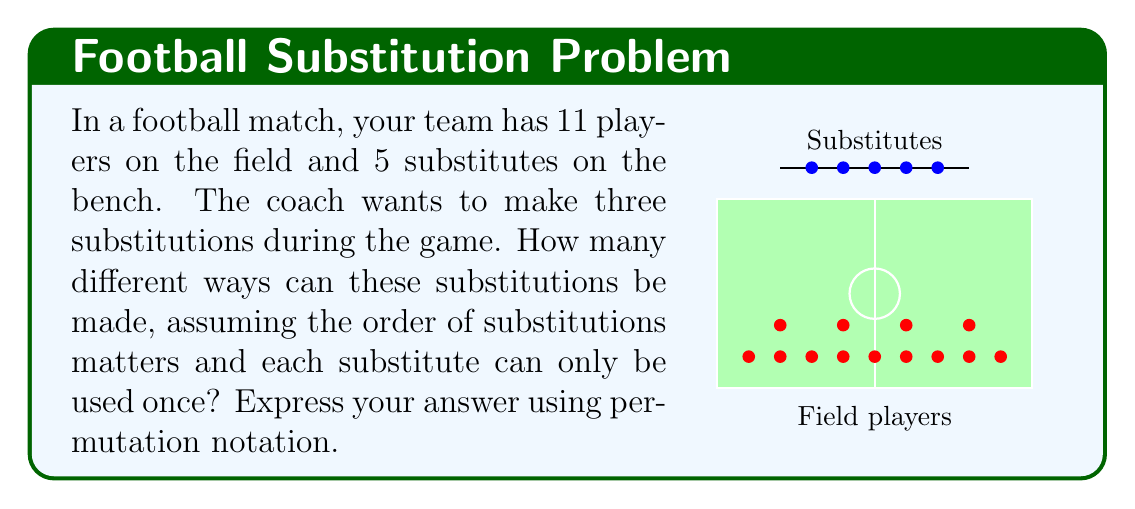Solve this math problem. Let's approach this step-by-step:

1) We are dealing with permutations here because the order of substitutions matters.

2) We have 5 substitutes to choose from for the first substitution, 4 for the second, and 3 for the third.

3) This scenario can be represented as a permutation of 5 elements taken 3 at a time.

4) The notation for this permutation is $P(5,3)$ or ${}_{5}P_{3}$.

5) The formula for this permutation is:

   $$P(5,3) = \frac{5!}{(5-3)!} = \frac{5!}{2!}$$

6) Let's calculate this:
   $$\frac{5!}{2!} = \frac{5 \times 4 \times 3 \times 2!}{2!} = 5 \times 4 \times 3 = 60$$

Therefore, there are 60 different ways to make these substitutions.
Answer: $P(5,3) = 60$ 